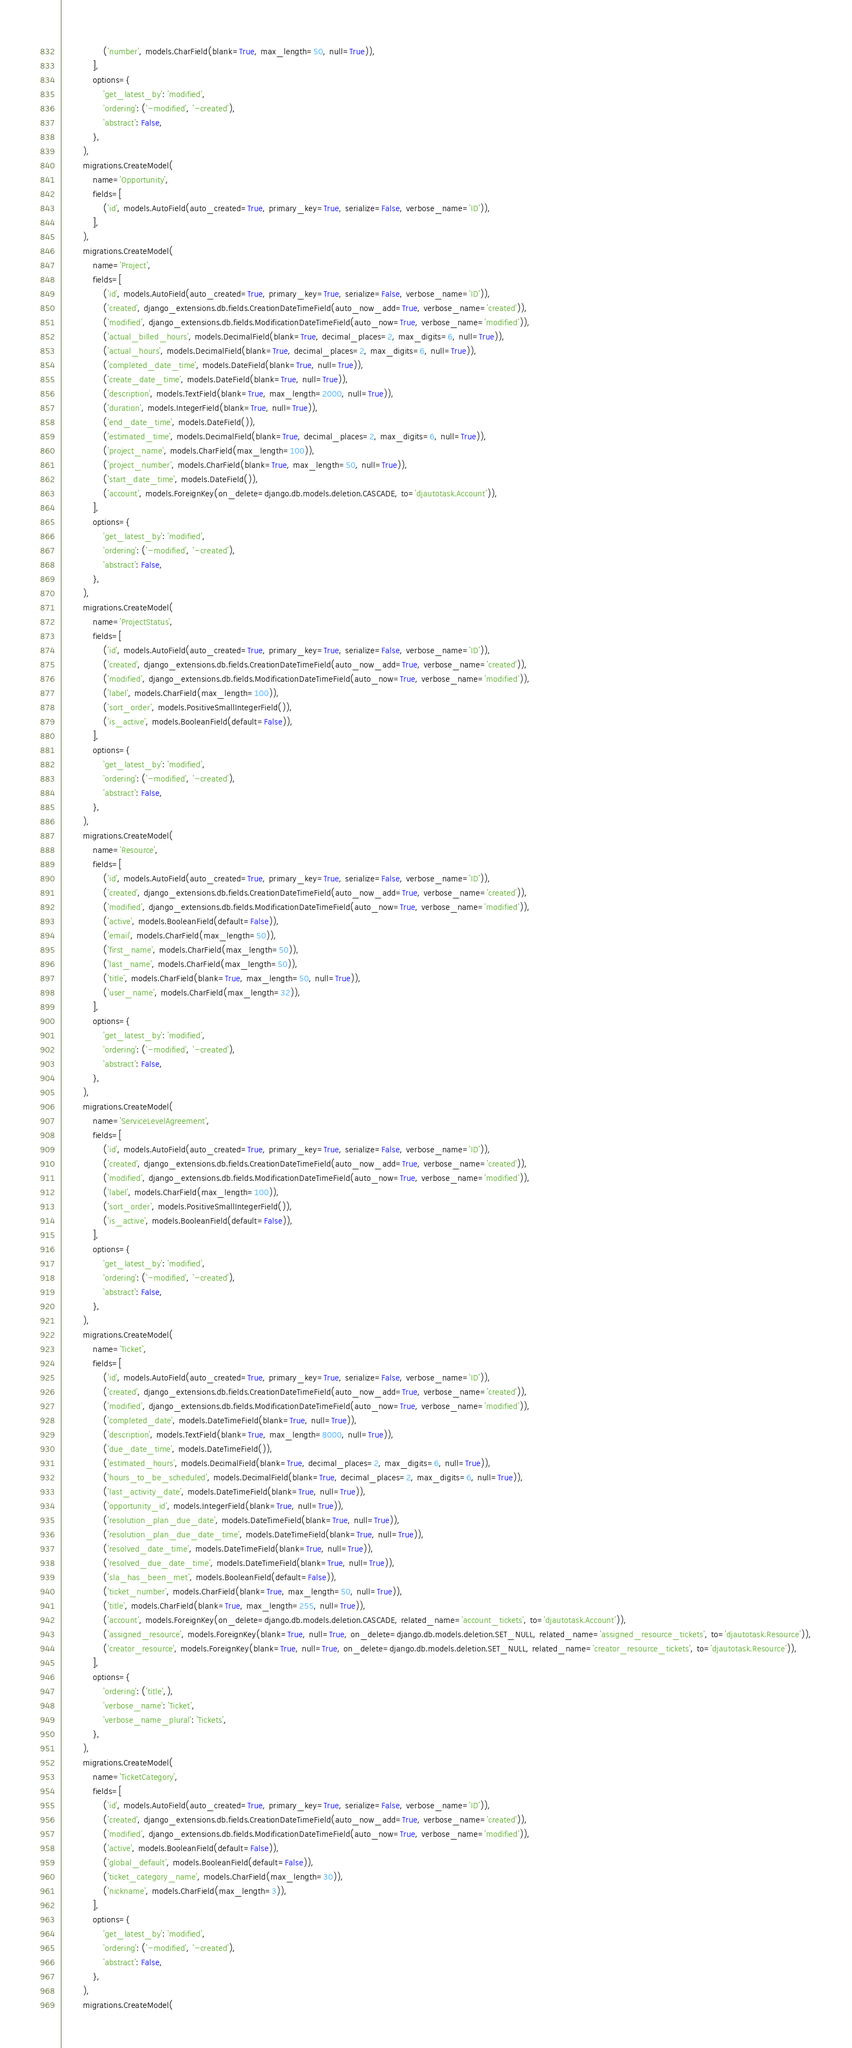Convert code to text. <code><loc_0><loc_0><loc_500><loc_500><_Python_>                ('number', models.CharField(blank=True, max_length=50, null=True)),
            ],
            options={
                'get_latest_by': 'modified',
                'ordering': ('-modified', '-created'),
                'abstract': False,
            },
        ),
        migrations.CreateModel(
            name='Opportunity',
            fields=[
                ('id', models.AutoField(auto_created=True, primary_key=True, serialize=False, verbose_name='ID')),
            ],
        ),
        migrations.CreateModel(
            name='Project',
            fields=[
                ('id', models.AutoField(auto_created=True, primary_key=True, serialize=False, verbose_name='ID')),
                ('created', django_extensions.db.fields.CreationDateTimeField(auto_now_add=True, verbose_name='created')),
                ('modified', django_extensions.db.fields.ModificationDateTimeField(auto_now=True, verbose_name='modified')),
                ('actual_billed_hours', models.DecimalField(blank=True, decimal_places=2, max_digits=6, null=True)),
                ('actual_hours', models.DecimalField(blank=True, decimal_places=2, max_digits=6, null=True)),
                ('completed_date_time', models.DateField(blank=True, null=True)),
                ('create_date_time', models.DateField(blank=True, null=True)),
                ('description', models.TextField(blank=True, max_length=2000, null=True)),
                ('duration', models.IntegerField(blank=True, null=True)),
                ('end_date_time', models.DateField()),
                ('estimated_time', models.DecimalField(blank=True, decimal_places=2, max_digits=6, null=True)),
                ('project_name', models.CharField(max_length=100)),
                ('project_number', models.CharField(blank=True, max_length=50, null=True)),
                ('start_date_time', models.DateField()),
                ('account', models.ForeignKey(on_delete=django.db.models.deletion.CASCADE, to='djautotask.Account')),
            ],
            options={
                'get_latest_by': 'modified',
                'ordering': ('-modified', '-created'),
                'abstract': False,
            },
        ),
        migrations.CreateModel(
            name='ProjectStatus',
            fields=[
                ('id', models.AutoField(auto_created=True, primary_key=True, serialize=False, verbose_name='ID')),
                ('created', django_extensions.db.fields.CreationDateTimeField(auto_now_add=True, verbose_name='created')),
                ('modified', django_extensions.db.fields.ModificationDateTimeField(auto_now=True, verbose_name='modified')),
                ('label', models.CharField(max_length=100)),
                ('sort_order', models.PositiveSmallIntegerField()),
                ('is_active', models.BooleanField(default=False)),
            ],
            options={
                'get_latest_by': 'modified',
                'ordering': ('-modified', '-created'),
                'abstract': False,
            },
        ),
        migrations.CreateModel(
            name='Resource',
            fields=[
                ('id', models.AutoField(auto_created=True, primary_key=True, serialize=False, verbose_name='ID')),
                ('created', django_extensions.db.fields.CreationDateTimeField(auto_now_add=True, verbose_name='created')),
                ('modified', django_extensions.db.fields.ModificationDateTimeField(auto_now=True, verbose_name='modified')),
                ('active', models.BooleanField(default=False)),
                ('email', models.CharField(max_length=50)),
                ('first_name', models.CharField(max_length=50)),
                ('last_name', models.CharField(max_length=50)),
                ('title', models.CharField(blank=True, max_length=50, null=True)),
                ('user_name', models.CharField(max_length=32)),
            ],
            options={
                'get_latest_by': 'modified',
                'ordering': ('-modified', '-created'),
                'abstract': False,
            },
        ),
        migrations.CreateModel(
            name='ServiceLevelAgreement',
            fields=[
                ('id', models.AutoField(auto_created=True, primary_key=True, serialize=False, verbose_name='ID')),
                ('created', django_extensions.db.fields.CreationDateTimeField(auto_now_add=True, verbose_name='created')),
                ('modified', django_extensions.db.fields.ModificationDateTimeField(auto_now=True, verbose_name='modified')),
                ('label', models.CharField(max_length=100)),
                ('sort_order', models.PositiveSmallIntegerField()),
                ('is_active', models.BooleanField(default=False)),
            ],
            options={
                'get_latest_by': 'modified',
                'ordering': ('-modified', '-created'),
                'abstract': False,
            },
        ),
        migrations.CreateModel(
            name='Ticket',
            fields=[
                ('id', models.AutoField(auto_created=True, primary_key=True, serialize=False, verbose_name='ID')),
                ('created', django_extensions.db.fields.CreationDateTimeField(auto_now_add=True, verbose_name='created')),
                ('modified', django_extensions.db.fields.ModificationDateTimeField(auto_now=True, verbose_name='modified')),
                ('completed_date', models.DateTimeField(blank=True, null=True)),
                ('description', models.TextField(blank=True, max_length=8000, null=True)),
                ('due_date_time', models.DateTimeField()),
                ('estimated_hours', models.DecimalField(blank=True, decimal_places=2, max_digits=6, null=True)),
                ('hours_to_be_scheduled', models.DecimalField(blank=True, decimal_places=2, max_digits=6, null=True)),
                ('last_activity_date', models.DateTimeField(blank=True, null=True)),
                ('opportunity_id', models.IntegerField(blank=True, null=True)),
                ('resolution_plan_due_date', models.DateTimeField(blank=True, null=True)),
                ('resolution_plan_due_date_time', models.DateTimeField(blank=True, null=True)),
                ('resolved_date_time', models.DateTimeField(blank=True, null=True)),
                ('resolved_due_date_time', models.DateTimeField(blank=True, null=True)),
                ('sla_has_been_met', models.BooleanField(default=False)),
                ('ticket_number', models.CharField(blank=True, max_length=50, null=True)),
                ('title', models.CharField(blank=True, max_length=255, null=True)),
                ('account', models.ForeignKey(on_delete=django.db.models.deletion.CASCADE, related_name='account_tickets', to='djautotask.Account')),
                ('assigned_resource', models.ForeignKey(blank=True, null=True, on_delete=django.db.models.deletion.SET_NULL, related_name='assigned_resource_tickets', to='djautotask.Resource')),
                ('creator_resource', models.ForeignKey(blank=True, null=True, on_delete=django.db.models.deletion.SET_NULL, related_name='creator_resource_tickets', to='djautotask.Resource')),
            ],
            options={
                'ordering': ('title',),
                'verbose_name': 'Ticket',
                'verbose_name_plural': 'Tickets',
            },
        ),
        migrations.CreateModel(
            name='TicketCategory',
            fields=[
                ('id', models.AutoField(auto_created=True, primary_key=True, serialize=False, verbose_name='ID')),
                ('created', django_extensions.db.fields.CreationDateTimeField(auto_now_add=True, verbose_name='created')),
                ('modified', django_extensions.db.fields.ModificationDateTimeField(auto_now=True, verbose_name='modified')),
                ('active', models.BooleanField(default=False)),
                ('global_default', models.BooleanField(default=False)),
                ('ticket_category_name', models.CharField(max_length=30)),
                ('nickname', models.CharField(max_length=3)),
            ],
            options={
                'get_latest_by': 'modified',
                'ordering': ('-modified', '-created'),
                'abstract': False,
            },
        ),
        migrations.CreateModel(</code> 